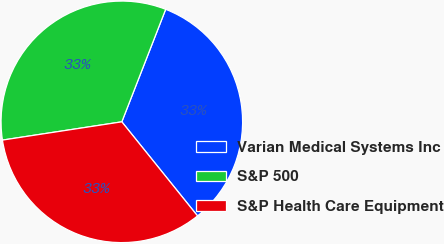Convert chart. <chart><loc_0><loc_0><loc_500><loc_500><pie_chart><fcel>Varian Medical Systems Inc<fcel>S&P 500<fcel>S&P Health Care Equipment<nl><fcel>33.3%<fcel>33.33%<fcel>33.37%<nl></chart> 